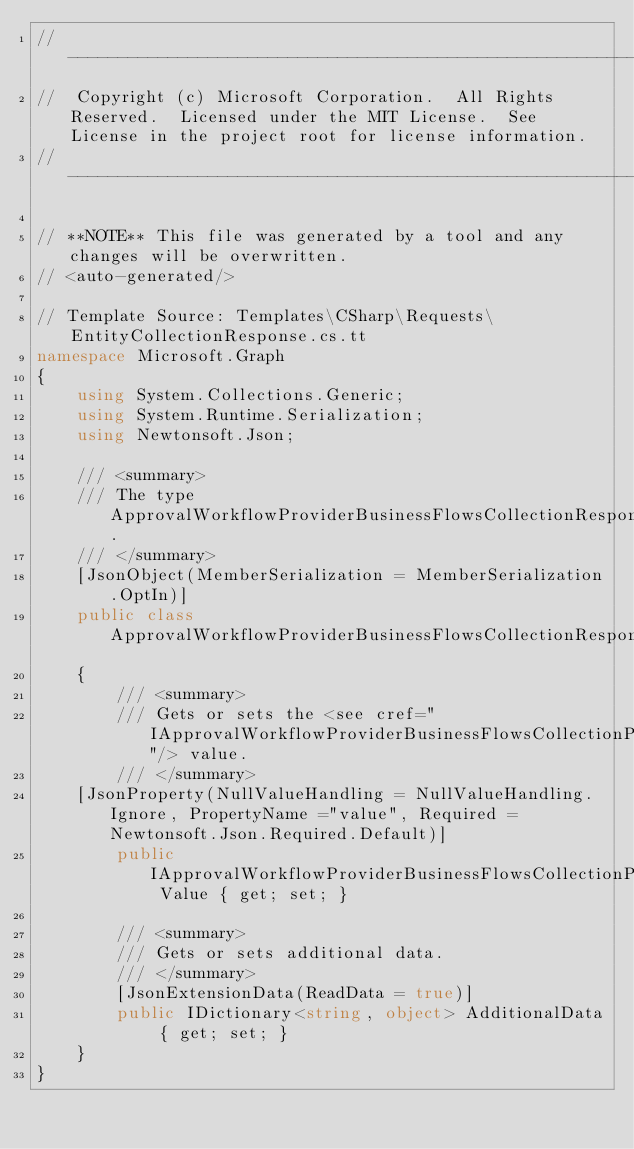<code> <loc_0><loc_0><loc_500><loc_500><_C#_>// ------------------------------------------------------------------------------
//  Copyright (c) Microsoft Corporation.  All Rights Reserved.  Licensed under the MIT License.  See License in the project root for license information.
// ------------------------------------------------------------------------------

// **NOTE** This file was generated by a tool and any changes will be overwritten.
// <auto-generated/>

// Template Source: Templates\CSharp\Requests\EntityCollectionResponse.cs.tt
namespace Microsoft.Graph
{
    using System.Collections.Generic;
    using System.Runtime.Serialization;
    using Newtonsoft.Json;

    /// <summary>
    /// The type ApprovalWorkflowProviderBusinessFlowsCollectionResponse.
    /// </summary>
    [JsonObject(MemberSerialization = MemberSerialization.OptIn)]
    public class ApprovalWorkflowProviderBusinessFlowsCollectionResponse
    {
        /// <summary>
        /// Gets or sets the <see cref="IApprovalWorkflowProviderBusinessFlowsCollectionPage"/> value.
        /// </summary>
		[JsonProperty(NullValueHandling = NullValueHandling.Ignore, PropertyName ="value", Required = Newtonsoft.Json.Required.Default)]
        public IApprovalWorkflowProviderBusinessFlowsCollectionPage Value { get; set; }

        /// <summary>
        /// Gets or sets additional data.
        /// </summary>
        [JsonExtensionData(ReadData = true)]
        public IDictionary<string, object> AdditionalData { get; set; }
    }
}
</code> 